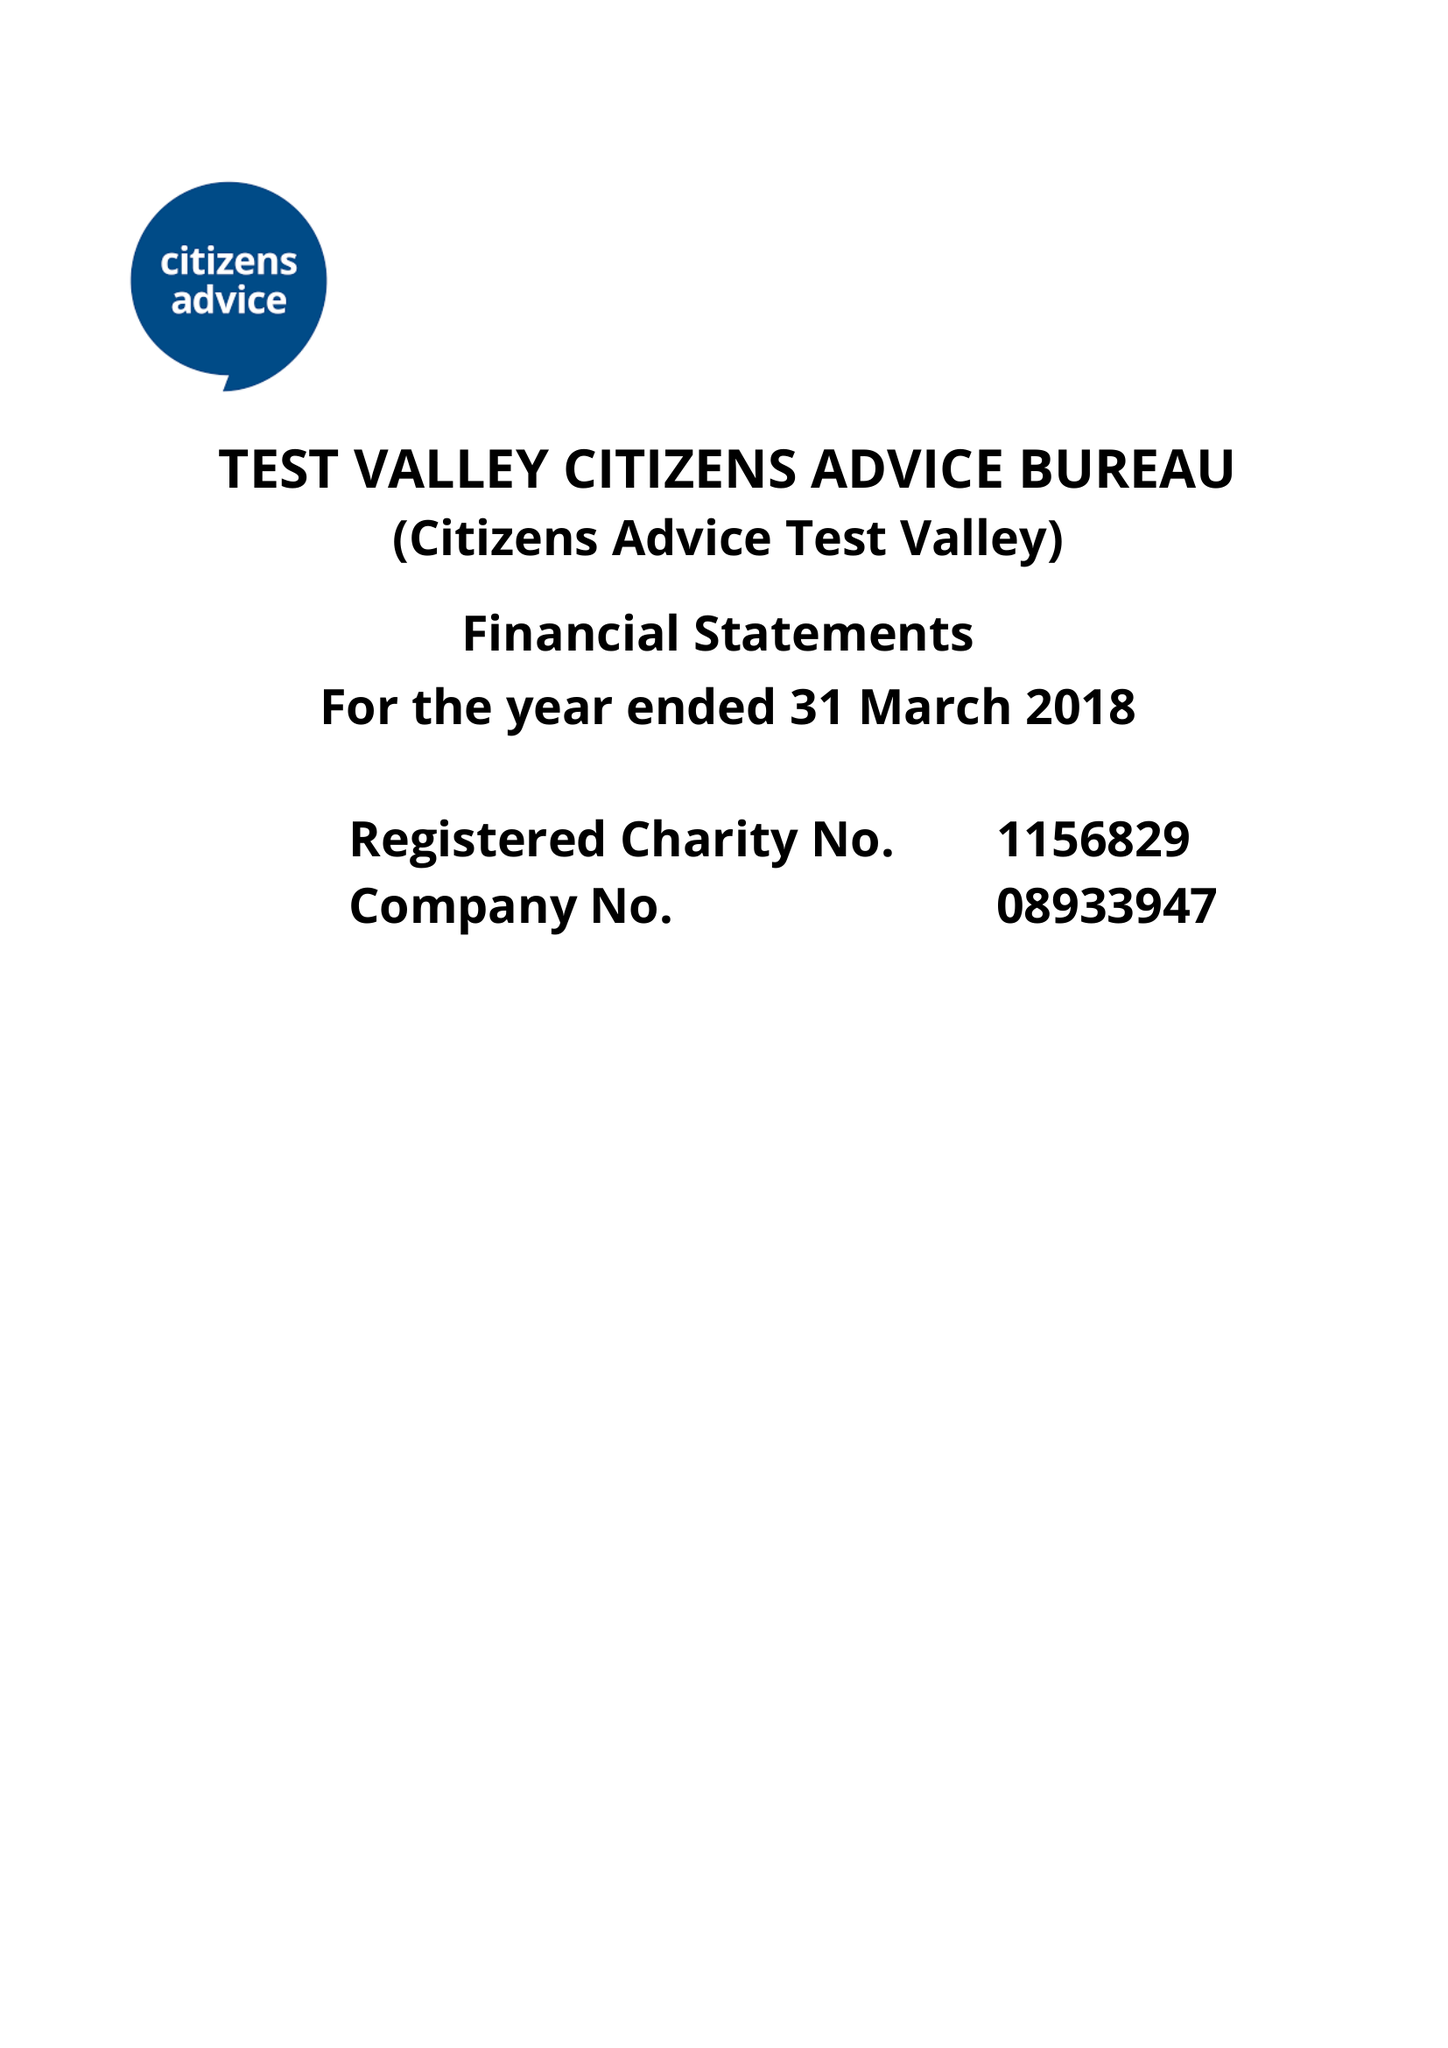What is the value for the address__post_town?
Answer the question using a single word or phrase. ANDOVER 